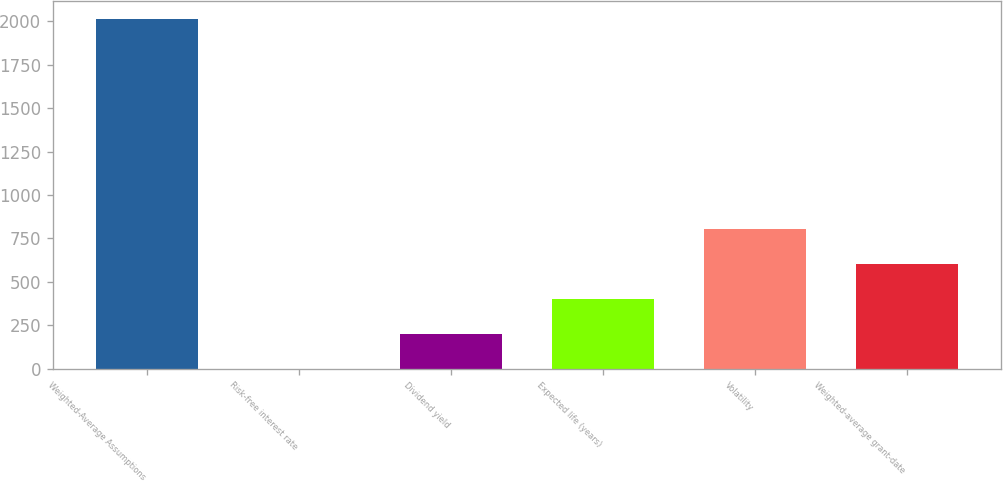Convert chart to OTSL. <chart><loc_0><loc_0><loc_500><loc_500><bar_chart><fcel>Weighted-Average Assumptions<fcel>Risk-free interest rate<fcel>Dividend yield<fcel>Expected life (years)<fcel>Volatility<fcel>Weighted-average grant-date<nl><fcel>2015<fcel>1.3<fcel>202.67<fcel>404.04<fcel>806.78<fcel>605.41<nl></chart> 